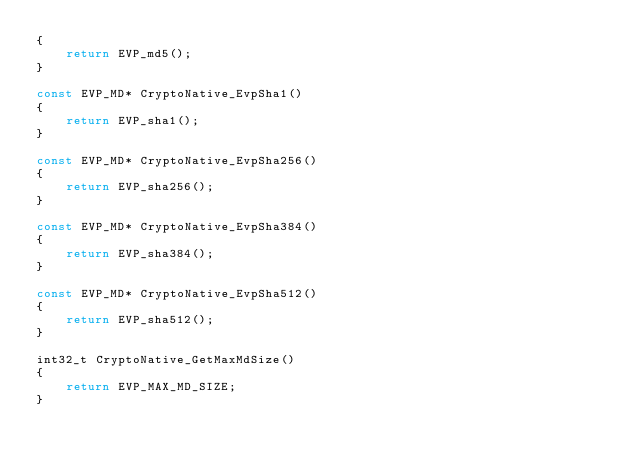Convert code to text. <code><loc_0><loc_0><loc_500><loc_500><_C_>{
    return EVP_md5();
}

const EVP_MD* CryptoNative_EvpSha1()
{
    return EVP_sha1();
}

const EVP_MD* CryptoNative_EvpSha256()
{
    return EVP_sha256();
}

const EVP_MD* CryptoNative_EvpSha384()
{
    return EVP_sha384();
}

const EVP_MD* CryptoNative_EvpSha512()
{
    return EVP_sha512();
}

int32_t CryptoNative_GetMaxMdSize()
{
    return EVP_MAX_MD_SIZE;
}
</code> 